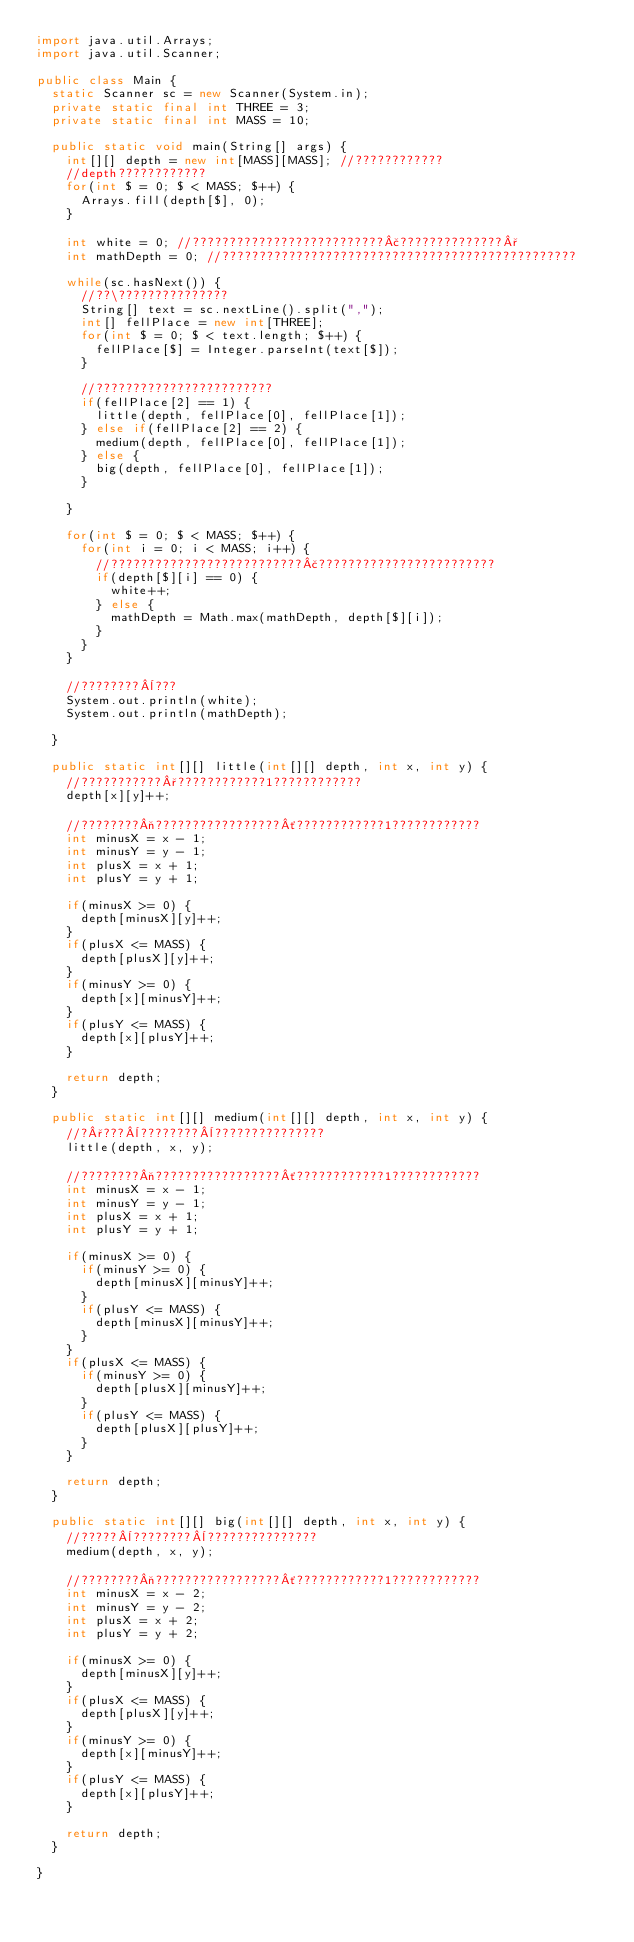<code> <loc_0><loc_0><loc_500><loc_500><_Java_>import java.util.Arrays;
import java.util.Scanner;

public class Main {
	static Scanner sc = new Scanner(System.in);
	private static final int THREE = 3;
	private static final int MASS = 10;

	public static void main(String[] args) {
		int[][] depth = new int[MASS][MASS]; //????????????
		//depth????????????
		for(int $ = 0; $ < MASS; $++) {
			Arrays.fill(depth[$], 0);
		}

		int white = 0; //??????????????????????????£??????????????°
		int mathDepth = 0; //????????????????????????????????????????????????

		while(sc.hasNext()) {
			//??\???????????????
			String[] text = sc.nextLine().split(",");
			int[] fellPlace = new int[THREE];
			for(int $ = 0; $ < text.length; $++) {
				fellPlace[$] = Integer.parseInt(text[$]);
			}

			//????????????????????????
			if(fellPlace[2] == 1) {
				little(depth, fellPlace[0], fellPlace[1]);
			} else if(fellPlace[2] == 2) {
				medium(depth, fellPlace[0], fellPlace[1]);
			} else {
				big(depth, fellPlace[0], fellPlace[1]);
			}

		}

		for(int $ = 0; $ < MASS; $++) {
			for(int i = 0; i < MASS; i++) {
				//??????????????????????????£????????????????????????
				if(depth[$][i] == 0) {
					white++;
				} else {
					mathDepth = Math.max(mathDepth, depth[$][i]);
				}
			}
		}

		//????????¨???
		System.out.println(white);
		System.out.println(mathDepth);

	}

	public static int[][] little(int[][] depth, int x, int y) {
		//???????????°????????????1????????????
		depth[x][y]++;

		//????????¬?????????????????´????????????1????????????
		int minusX = x - 1;
		int minusY = y - 1;
		int plusX = x + 1;
		int plusY = y + 1;

		if(minusX >= 0) {
			depth[minusX][y]++;
		}
		if(plusX <= MASS) {
			depth[plusX][y]++;
		}
		if(minusY >= 0) {
			depth[x][minusY]++;
		}
		if(plusY <= MASS) {
			depth[x][plusY]++;
		}

		return depth;
	}

	public static int[][] medium(int[][] depth, int x, int y) {
		//?°???¨????????¨???????????????
		little(depth, x, y);

		//????????¬?????????????????´????????????1????????????
		int minusX = x - 1;
		int minusY = y - 1;
		int plusX = x + 1;
		int plusY = y + 1;

		if(minusX >= 0) {
			if(minusY >= 0) {
				depth[minusX][minusY]++;
			}
			if(plusY <= MASS) {
				depth[minusX][minusY]++;
			}
		}
		if(plusX <= MASS) {
			if(minusY >= 0) {
				depth[plusX][minusY]++;
			}
			if(plusY <= MASS) {
				depth[plusX][plusY]++;
			}
		}

		return depth;
	}

	public static int[][] big(int[][] depth, int x, int y) {
		//?????¨????????¨???????????????
		medium(depth, x, y);

		//????????¬?????????????????´????????????1????????????
		int minusX = x - 2;
		int minusY = y - 2;
		int plusX = x + 2;
		int plusY = y + 2;

		if(minusX >= 0) {
			depth[minusX][y]++;
		}
		if(plusX <= MASS) {
			depth[plusX][y]++;
		}
		if(minusY >= 0) {
			depth[x][minusY]++;
		}
		if(plusY <= MASS) {
			depth[x][plusY]++;
		}

		return depth;
	}

}</code> 